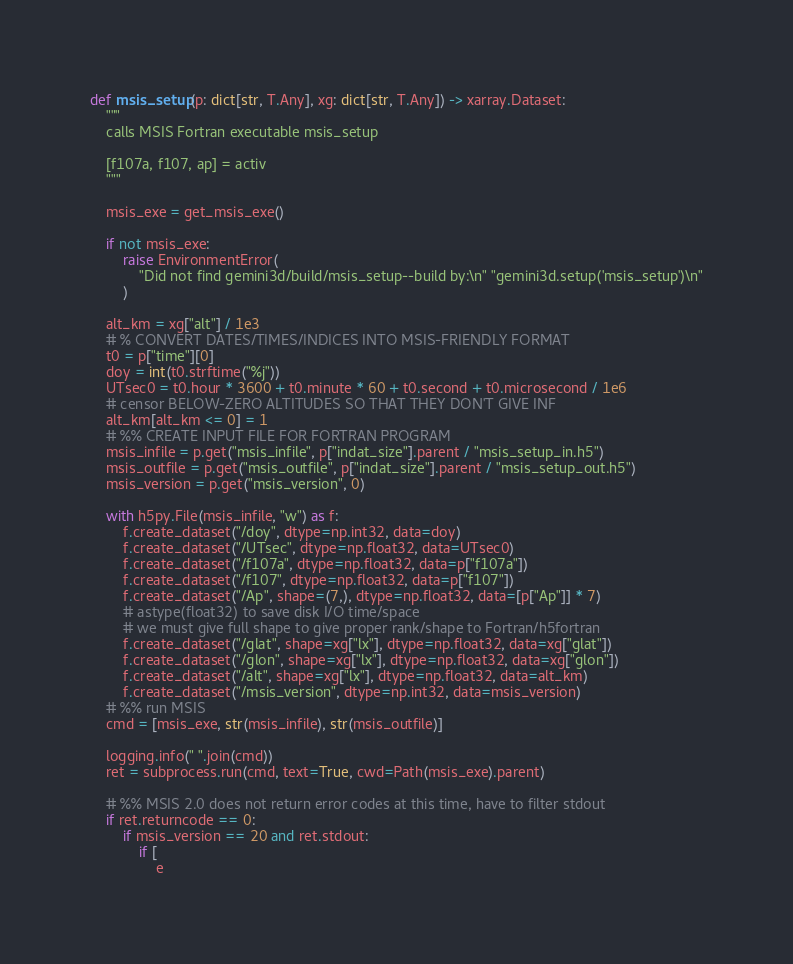<code> <loc_0><loc_0><loc_500><loc_500><_Python_>def msis_setup(p: dict[str, T.Any], xg: dict[str, T.Any]) -> xarray.Dataset:
    """
    calls MSIS Fortran executable msis_setup

    [f107a, f107, ap] = activ
    """

    msis_exe = get_msis_exe()

    if not msis_exe:
        raise EnvironmentError(
            "Did not find gemini3d/build/msis_setup--build by:\n" "gemini3d.setup('msis_setup')\n"
        )

    alt_km = xg["alt"] / 1e3
    # % CONVERT DATES/TIMES/INDICES INTO MSIS-FRIENDLY FORMAT
    t0 = p["time"][0]
    doy = int(t0.strftime("%j"))
    UTsec0 = t0.hour * 3600 + t0.minute * 60 + t0.second + t0.microsecond / 1e6
    # censor BELOW-ZERO ALTITUDES SO THAT THEY DON'T GIVE INF
    alt_km[alt_km <= 0] = 1
    # %% CREATE INPUT FILE FOR FORTRAN PROGRAM
    msis_infile = p.get("msis_infile", p["indat_size"].parent / "msis_setup_in.h5")
    msis_outfile = p.get("msis_outfile", p["indat_size"].parent / "msis_setup_out.h5")
    msis_version = p.get("msis_version", 0)

    with h5py.File(msis_infile, "w") as f:
        f.create_dataset("/doy", dtype=np.int32, data=doy)
        f.create_dataset("/UTsec", dtype=np.float32, data=UTsec0)
        f.create_dataset("/f107a", dtype=np.float32, data=p["f107a"])
        f.create_dataset("/f107", dtype=np.float32, data=p["f107"])
        f.create_dataset("/Ap", shape=(7,), dtype=np.float32, data=[p["Ap"]] * 7)
        # astype(float32) to save disk I/O time/space
        # we must give full shape to give proper rank/shape to Fortran/h5fortran
        f.create_dataset("/glat", shape=xg["lx"], dtype=np.float32, data=xg["glat"])
        f.create_dataset("/glon", shape=xg["lx"], dtype=np.float32, data=xg["glon"])
        f.create_dataset("/alt", shape=xg["lx"], dtype=np.float32, data=alt_km)
        f.create_dataset("/msis_version", dtype=np.int32, data=msis_version)
    # %% run MSIS
    cmd = [msis_exe, str(msis_infile), str(msis_outfile)]

    logging.info(" ".join(cmd))
    ret = subprocess.run(cmd, text=True, cwd=Path(msis_exe).parent)

    # %% MSIS 2.0 does not return error codes at this time, have to filter stdout
    if ret.returncode == 0:
        if msis_version == 20 and ret.stdout:
            if [
                e</code> 